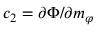<formula> <loc_0><loc_0><loc_500><loc_500>c _ { 2 } = \partial \Phi / \partial m _ { \varphi }</formula> 